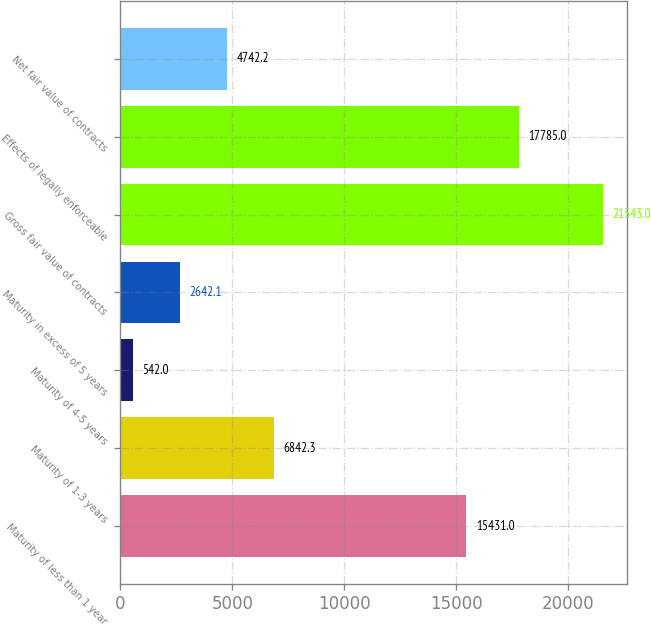Convert chart to OTSL. <chart><loc_0><loc_0><loc_500><loc_500><bar_chart><fcel>Maturity of less than 1 year<fcel>Maturity of 1-3 years<fcel>Maturity of 4-5 years<fcel>Maturity in excess of 5 years<fcel>Gross fair value of contracts<fcel>Effects of legally enforceable<fcel>Net fair value of contracts<nl><fcel>15431<fcel>6842.3<fcel>542<fcel>2642.1<fcel>21543<fcel>17785<fcel>4742.2<nl></chart> 